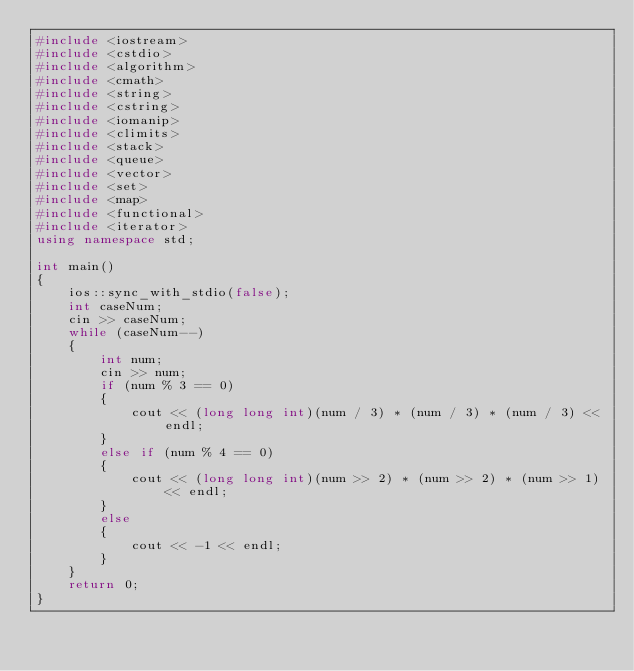<code> <loc_0><loc_0><loc_500><loc_500><_C++_>#include <iostream>
#include <cstdio>
#include <algorithm>
#include <cmath>
#include <string>
#include <cstring>
#include <iomanip>
#include <climits>
#include <stack>
#include <queue>
#include <vector>
#include <set>
#include <map>
#include <functional>
#include <iterator>
using namespace std;

int main()
{
    ios::sync_with_stdio(false);
    int caseNum;
    cin >> caseNum;
    while (caseNum--)
    {
        int num;
        cin >> num;
        if (num % 3 == 0)
        {
            cout << (long long int)(num / 3) * (num / 3) * (num / 3) << endl;
        }
        else if (num % 4 == 0)
        {
            cout << (long long int)(num >> 2) * (num >> 2) * (num >> 1) << endl;
        }
        else
        {
            cout << -1 << endl;
        }
    }
    return 0;
}</code> 